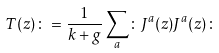Convert formula to latex. <formula><loc_0><loc_0><loc_500><loc_500>T ( z ) \colon = \frac { 1 } { k + g } \sum _ { a } \colon J ^ { a } ( z ) J ^ { a } ( z ) \colon</formula> 